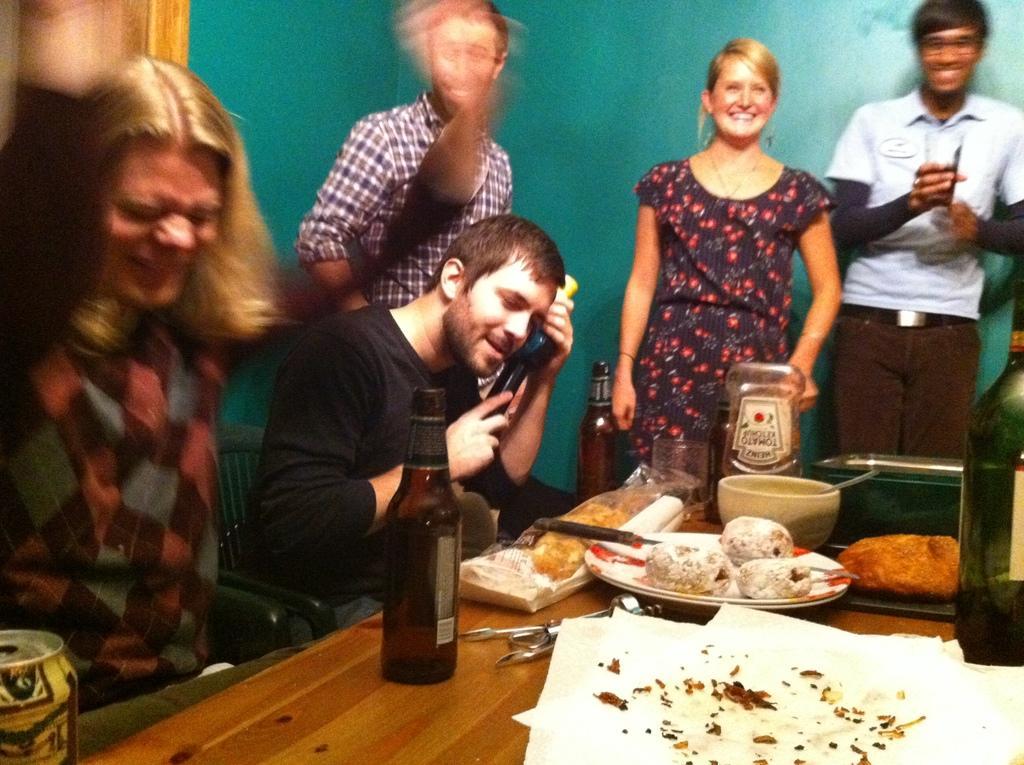Please provide a concise description of this image. This picture describes about group of people few are seated in the chair and few are standing, in front of them we can see food, plates, bottles on the table. 